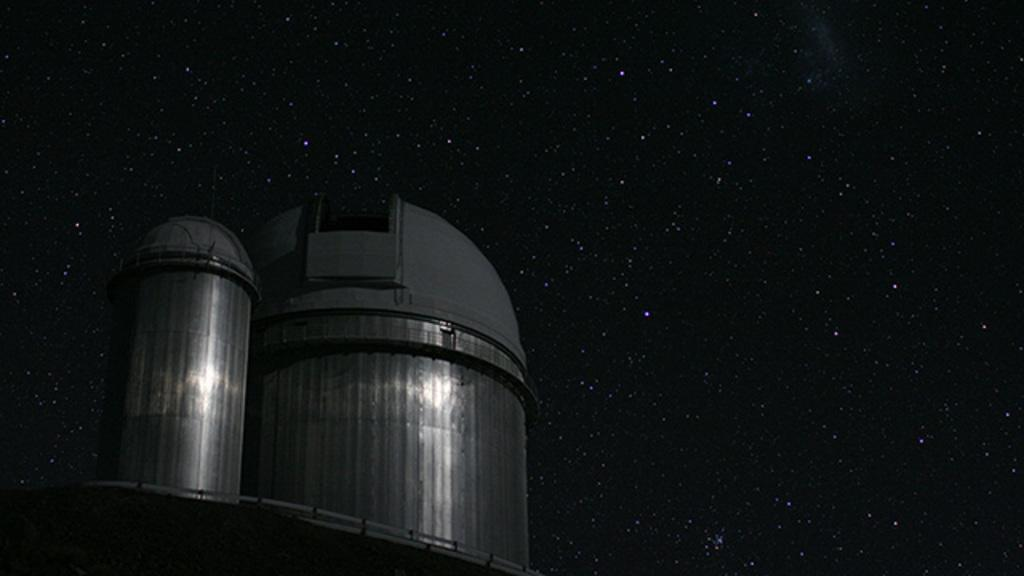What is located on the left side of the image? There is an unspecified "thing" on the left side of the image. What can be seen in the background of the image? The night sky is visible in the image. How would you describe the appearance of the night sky? The night sky is dark in the image. What celestial objects can be seen in the night sky? Stars are present in the night sky. What type of soup is being served in the image? There is no soup present in the image; it features an unspecified "thing" on the left side and the night sky in the background. Can you see any nuts in the image? There are no nuts visible in the image. 